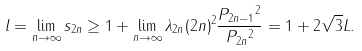<formula> <loc_0><loc_0><loc_500><loc_500>l = \lim _ { n \to \infty } s _ { 2 n } \geq 1 + \lim _ { n \to \infty } \lambda _ { 2 n } ( 2 n ) ^ { 2 } \frac { \| P _ { 2 n - 1 } \| ^ { 2 } } { \| P _ { 2 n } \| ^ { 2 } } = 1 + 2 \sqrt { 3 } L .</formula> 